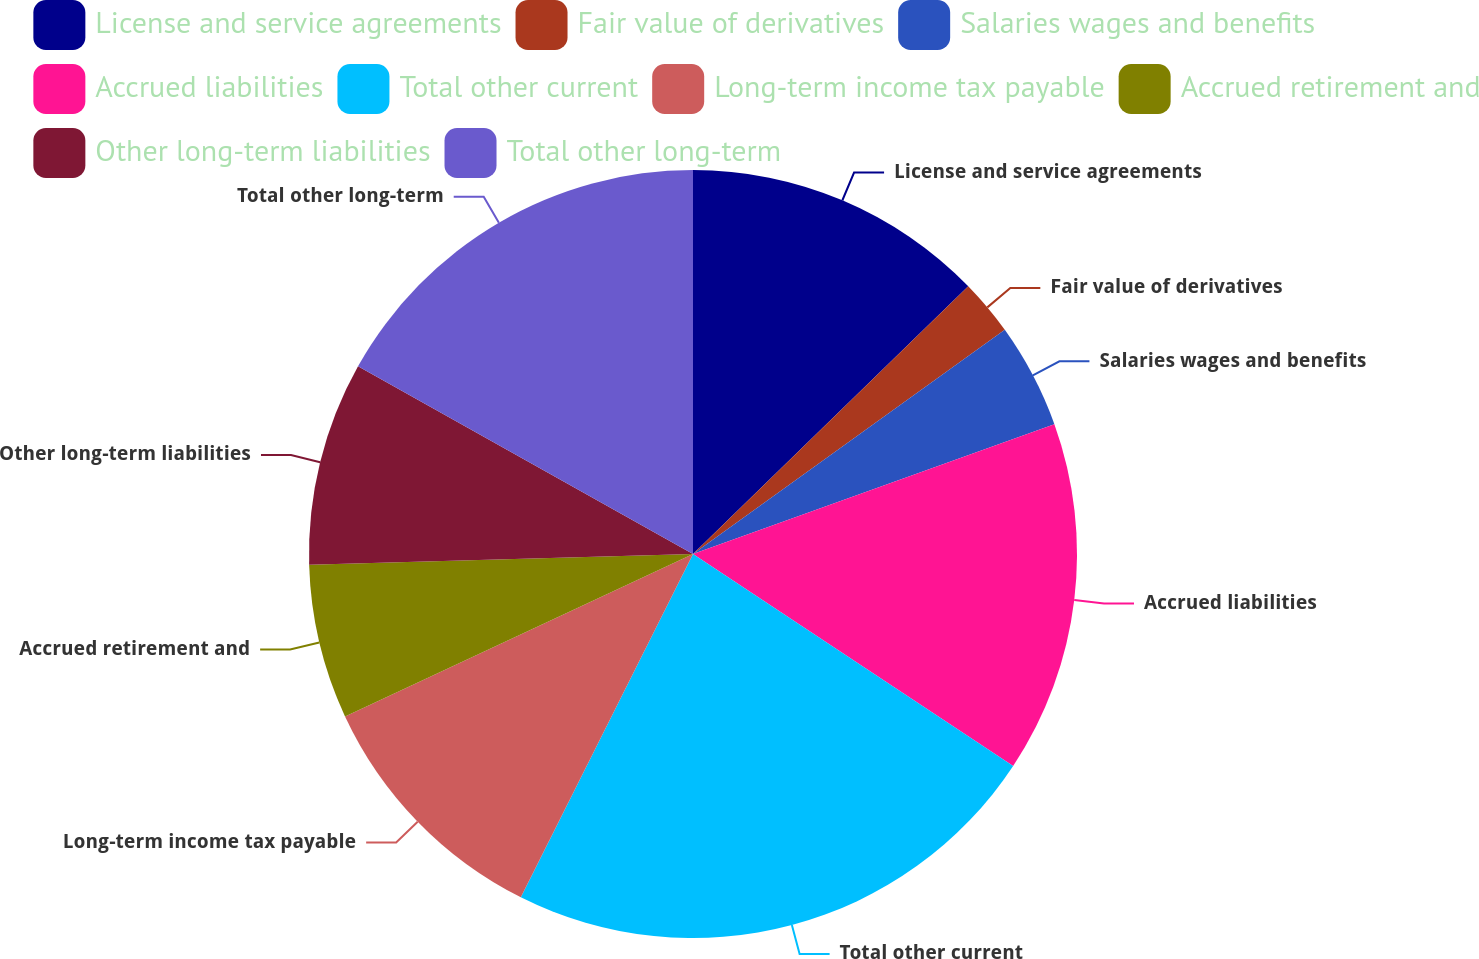<chart> <loc_0><loc_0><loc_500><loc_500><pie_chart><fcel>License and service agreements<fcel>Fair value of derivatives<fcel>Salaries wages and benefits<fcel>Accrued liabilities<fcel>Total other current<fcel>Long-term income tax payable<fcel>Accrued retirement and<fcel>Other long-term liabilities<fcel>Total other long-term<nl><fcel>12.72%<fcel>2.36%<fcel>4.43%<fcel>14.8%<fcel>23.09%<fcel>10.65%<fcel>6.5%<fcel>8.58%<fcel>16.87%<nl></chart> 